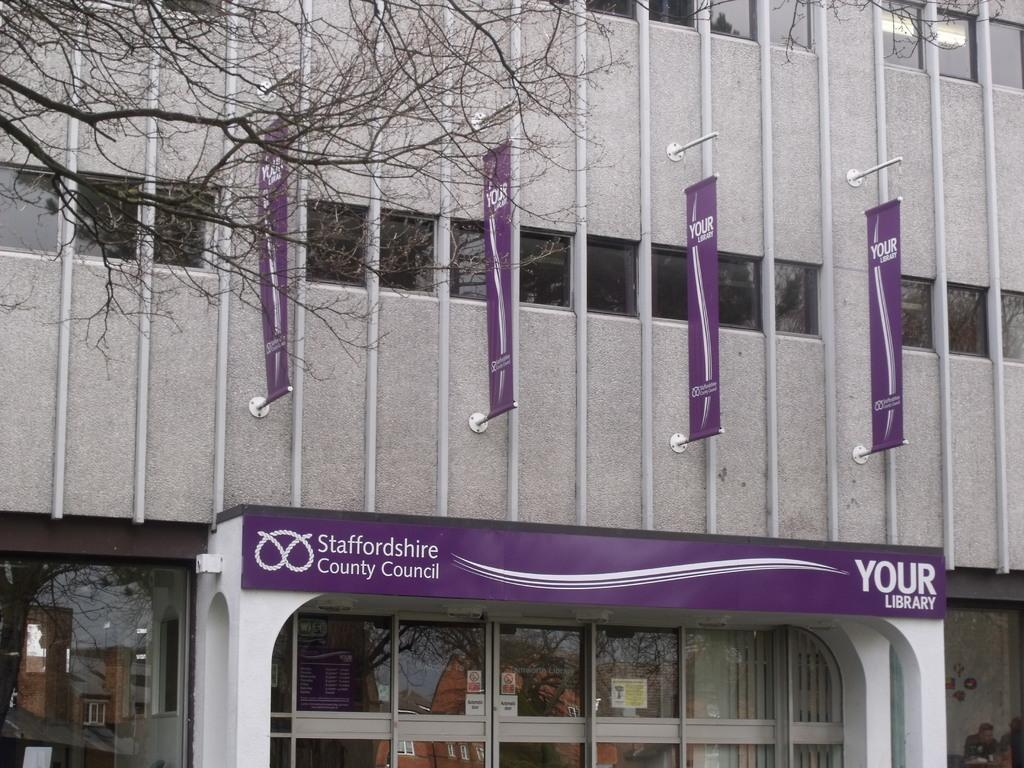What type of structures can be seen in the image? There are buildings in the image. What additional features are present in the image? There are advertisement flags and poles in the image. What can be seen on the buildings in the image? There are windows in the image. What type of establishment is depicted in the image? There is a store in the image. What type of disgusting smell can be detected in the image? There is no mention of any smell, pleasant or unpleasant, in the image. 